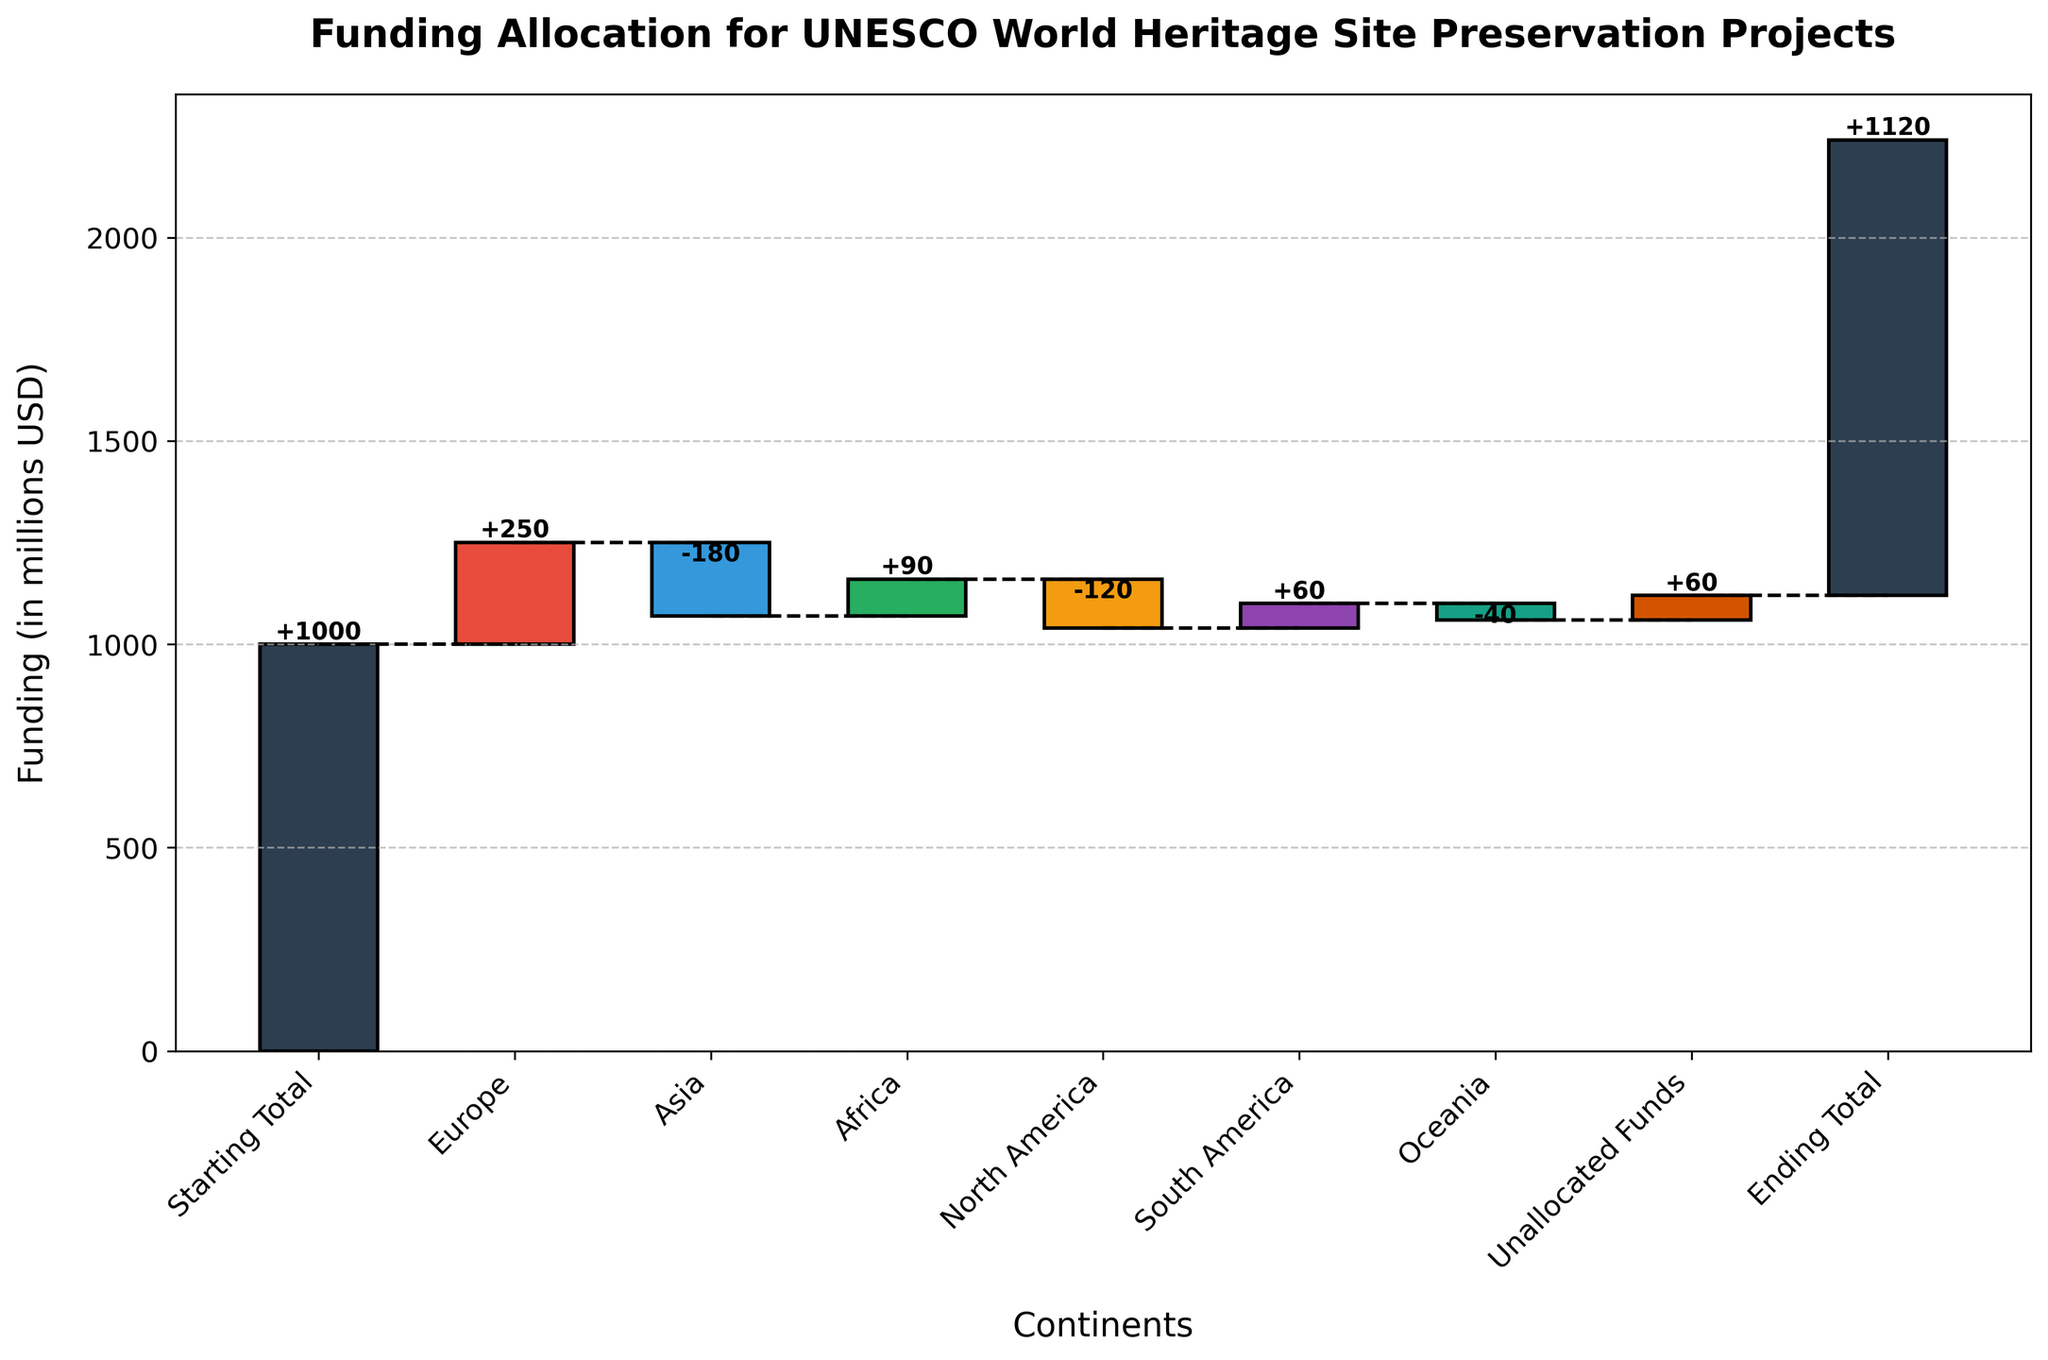What's the title of the chart? The title is located at the top of the chart and summarizes the overall topic of the visualization. In this case, it states "Funding Allocation for UNESCO World Heritage Site Preservation Projects".
Answer: Funding Allocation for UNESCO World Heritage Site Preservation Projects How much funding is allocated to Europe? Locate the bar labeled "Europe" and read the value indicated on or above the bar. The positive value shows the allocation amount. For Europe, it shows +250.
Answer: +250 million USD Which continent has the least funding allocated? By comparing the lengths of bars or their values, identify the smallest bar that represents a continent (negative or least positive value). Oceania has the least funding with -40.
Answer: Oceania What is the total change in funding due to the allocations for Asia and North America combined? To find the combined effect, add the values for Asia and North America. Asia is -180 and North America is -120, so the total change is -180 + (-120) = -300.
Answer: -300 million USD How is the "Ending Total" calculated? The "Ending Total" is calculated by starting with the "Starting Total" and adding up all the allocations, including both positive and negative values. Start with 1000, add 250 (Europe), subtract 180 (Asia), add 90 (Africa), subtract 120 (North America), add 60 (South America), and subtract 40 (Oceania), then add the Unallocated Funds (60). Thus, 1000 + 250 - 180 + 90 - 120 + 60 - 40 + 60 = 1120.
Answer: 1120 million USD Which continent experienced a decrease in funding relative to the previous category? Examine each continent's bar value; a decrease is indicated by negative values. Asia and North America both show decreases, with -180 and -120 respectively, relative to their previous values.
Answer: Asia and North America What is the difference in funding allocation between Africa and South America? Identify the values for both Africa and South America and subtract one from the other. Africa is at +90 and South America is at +60, so 90 - 60 = 30.
Answer: 30 million USD How many categories are displayed in the chart including starting and ending totals? Count all distinct elements on the x-axis starting from "Starting Total" to "Ending Total". Including all continents and "Unallocated Funds", there are 8 categories displayed.
Answer: 8 What does the color coding of the bars represent? Observe the colors of the bars while understanding their values. Positive values are represented with one set of colors, whereas negative values are represented with a different set. This color differentiation helps to easily identify increases and decreases in funding.
Answer: Differentiate positive and negative funding allocations Is there any category with a zero value, and if so, which one? Check all the bars to see if any of them have values of zero. In this dataset, no bar represents a zero value; all bars show either positive or negative values.
Answer: No 